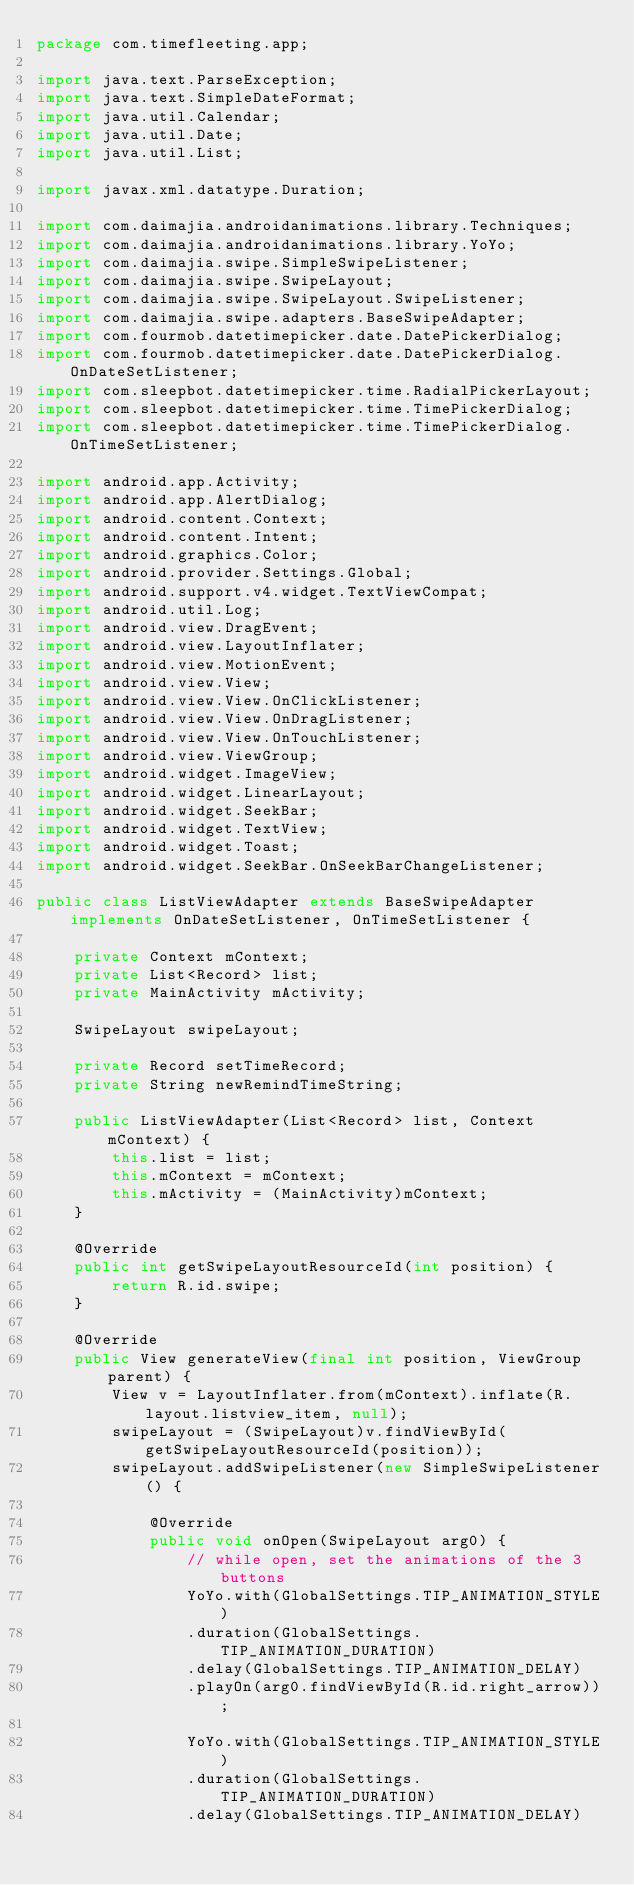<code> <loc_0><loc_0><loc_500><loc_500><_Java_>package com.timefleeting.app;

import java.text.ParseException;
import java.text.SimpleDateFormat;
import java.util.Calendar;
import java.util.Date;
import java.util.List;

import javax.xml.datatype.Duration;

import com.daimajia.androidanimations.library.Techniques;
import com.daimajia.androidanimations.library.YoYo;
import com.daimajia.swipe.SimpleSwipeListener;
import com.daimajia.swipe.SwipeLayout;
import com.daimajia.swipe.SwipeLayout.SwipeListener;
import com.daimajia.swipe.adapters.BaseSwipeAdapter;
import com.fourmob.datetimepicker.date.DatePickerDialog;
import com.fourmob.datetimepicker.date.DatePickerDialog.OnDateSetListener;
import com.sleepbot.datetimepicker.time.RadialPickerLayout;
import com.sleepbot.datetimepicker.time.TimePickerDialog;
import com.sleepbot.datetimepicker.time.TimePickerDialog.OnTimeSetListener;

import android.app.Activity;
import android.app.AlertDialog;
import android.content.Context;
import android.content.Intent;
import android.graphics.Color;
import android.provider.Settings.Global;
import android.support.v4.widget.TextViewCompat;
import android.util.Log;
import android.view.DragEvent;
import android.view.LayoutInflater;
import android.view.MotionEvent;
import android.view.View;
import android.view.View.OnClickListener;
import android.view.View.OnDragListener;
import android.view.View.OnTouchListener;
import android.view.ViewGroup;
import android.widget.ImageView;
import android.widget.LinearLayout;
import android.widget.SeekBar;
import android.widget.TextView;
import android.widget.Toast;
import android.widget.SeekBar.OnSeekBarChangeListener;

public class ListViewAdapter extends BaseSwipeAdapter implements OnDateSetListener, OnTimeSetListener {
	
    private Context mContext;
    private List<Record> list;
    private MainActivity mActivity;
    
    SwipeLayout swipeLayout;

    private Record setTimeRecord;
    private String newRemindTimeString;
    
    public ListViewAdapter(List<Record> list, Context mContext) {
    	this.list = list;
        this.mContext = mContext;
        this.mActivity = (MainActivity)mContext;
    }

    @Override
    public int getSwipeLayoutResourceId(int position) {
        return R.id.swipe;
    }

    @Override
    public View generateView(final int position, ViewGroup parent) {
        View v = LayoutInflater.from(mContext).inflate(R.layout.listview_item, null);
        swipeLayout = (SwipeLayout)v.findViewById(getSwipeLayoutResourceId(position));
        swipeLayout.addSwipeListener(new SimpleSwipeListener() {
			
			@Override
			public void onOpen(SwipeLayout arg0) {
				// while open, set the animations of the 3 buttons
				YoYo.with(GlobalSettings.TIP_ANIMATION_STYLE)
				.duration(GlobalSettings.TIP_ANIMATION_DURATION)
				.delay(GlobalSettings.TIP_ANIMATION_DELAY)
				.playOn(arg0.findViewById(R.id.right_arrow));
				
				YoYo.with(GlobalSettings.TIP_ANIMATION_STYLE)
				.duration(GlobalSettings.TIP_ANIMATION_DURATION)
				.delay(GlobalSettings.TIP_ANIMATION_DELAY)</code> 